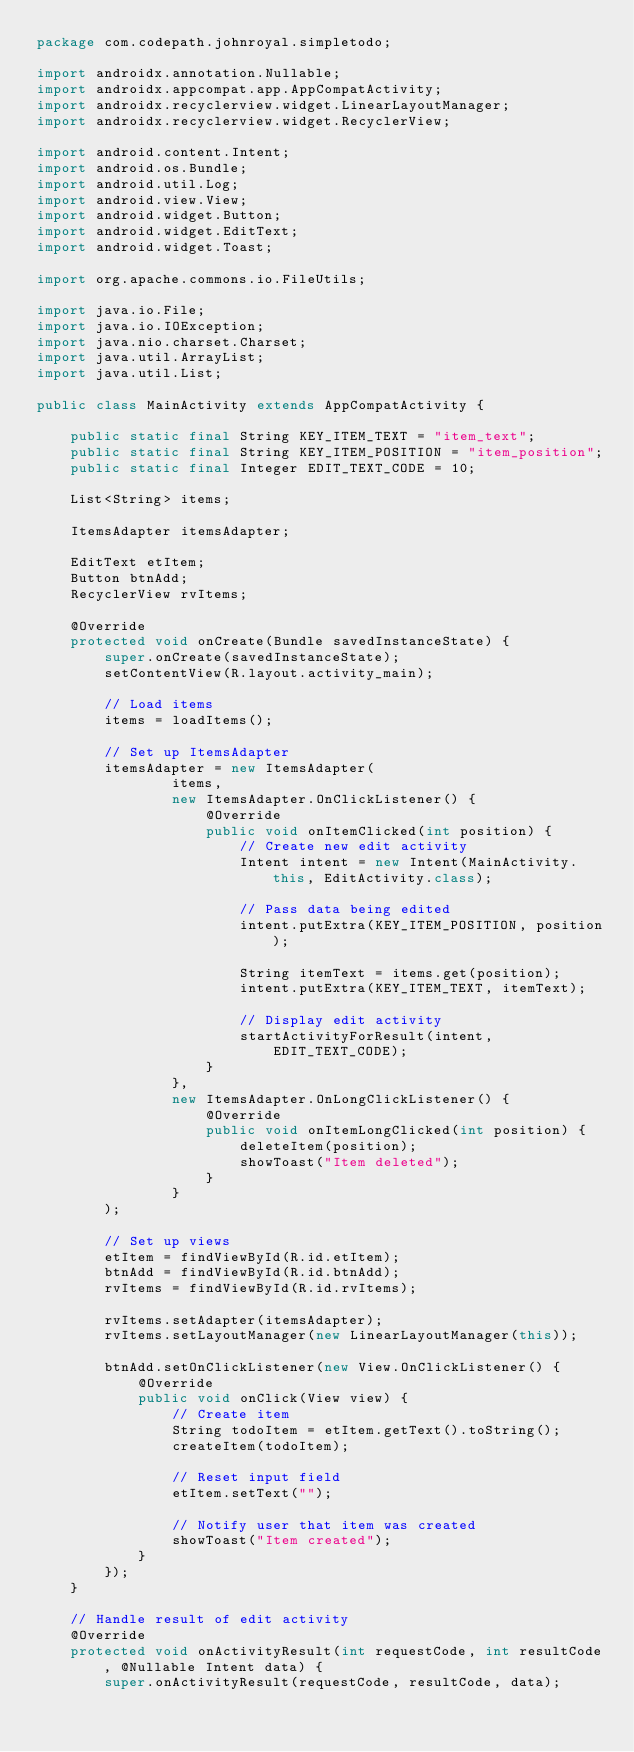Convert code to text. <code><loc_0><loc_0><loc_500><loc_500><_Java_>package com.codepath.johnroyal.simpletodo;

import androidx.annotation.Nullable;
import androidx.appcompat.app.AppCompatActivity;
import androidx.recyclerview.widget.LinearLayoutManager;
import androidx.recyclerview.widget.RecyclerView;

import android.content.Intent;
import android.os.Bundle;
import android.util.Log;
import android.view.View;
import android.widget.Button;
import android.widget.EditText;
import android.widget.Toast;

import org.apache.commons.io.FileUtils;

import java.io.File;
import java.io.IOException;
import java.nio.charset.Charset;
import java.util.ArrayList;
import java.util.List;

public class MainActivity extends AppCompatActivity {

    public static final String KEY_ITEM_TEXT = "item_text";
    public static final String KEY_ITEM_POSITION = "item_position";
    public static final Integer EDIT_TEXT_CODE = 10;

    List<String> items;

    ItemsAdapter itemsAdapter;

    EditText etItem;
    Button btnAdd;
    RecyclerView rvItems;

    @Override
    protected void onCreate(Bundle savedInstanceState) {
        super.onCreate(savedInstanceState);
        setContentView(R.layout.activity_main);

        // Load items
        items = loadItems();

        // Set up ItemsAdapter
        itemsAdapter = new ItemsAdapter(
                items,
                new ItemsAdapter.OnClickListener() {
                    @Override
                    public void onItemClicked(int position) {
                        // Create new edit activity
                        Intent intent = new Intent(MainActivity.this, EditActivity.class);

                        // Pass data being edited
                        intent.putExtra(KEY_ITEM_POSITION, position);

                        String itemText = items.get(position);
                        intent.putExtra(KEY_ITEM_TEXT, itemText);

                        // Display edit activity
                        startActivityForResult(intent, EDIT_TEXT_CODE);
                    }
                },
                new ItemsAdapter.OnLongClickListener() {
                    @Override
                    public void onItemLongClicked(int position) {
                        deleteItem(position);
                        showToast("Item deleted");
                    }
                }
        );

        // Set up views
        etItem = findViewById(R.id.etItem);
        btnAdd = findViewById(R.id.btnAdd);
        rvItems = findViewById(R.id.rvItems);

        rvItems.setAdapter(itemsAdapter);
        rvItems.setLayoutManager(new LinearLayoutManager(this));

        btnAdd.setOnClickListener(new View.OnClickListener() {
            @Override
            public void onClick(View view) {
                // Create item
                String todoItem = etItem.getText().toString();
                createItem(todoItem);

                // Reset input field
                etItem.setText("");

                // Notify user that item was created
                showToast("Item created");
            }
        });
    }

    // Handle result of edit activity
    @Override
    protected void onActivityResult(int requestCode, int resultCode, @Nullable Intent data) {
        super.onActivityResult(requestCode, resultCode, data);</code> 